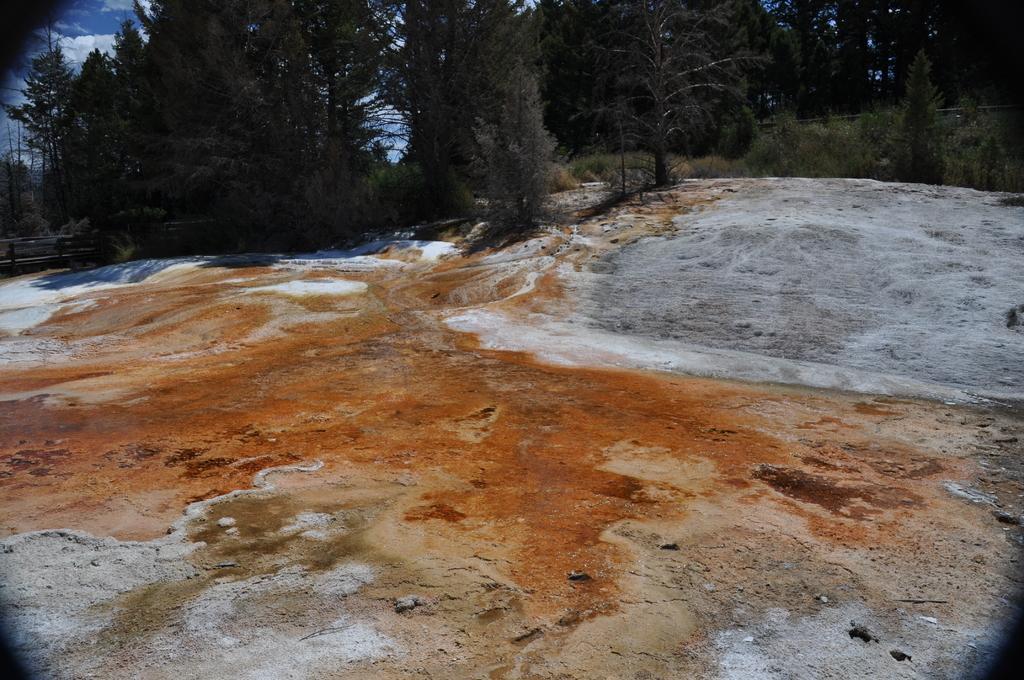In one or two sentences, can you explain what this image depicts? In the center of the image there is a rock. In the background we can see trees and sky. 